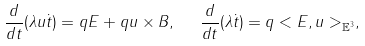<formula> <loc_0><loc_0><loc_500><loc_500>\frac { d } { d t } ( \lambda u \dot { t } ) = q E + q u \times B , \text { \ } \frac { d } { d t } ( \lambda \dot { t } ) = q < E , u > _ { \mathbb { E } ^ { 3 } } ,</formula> 